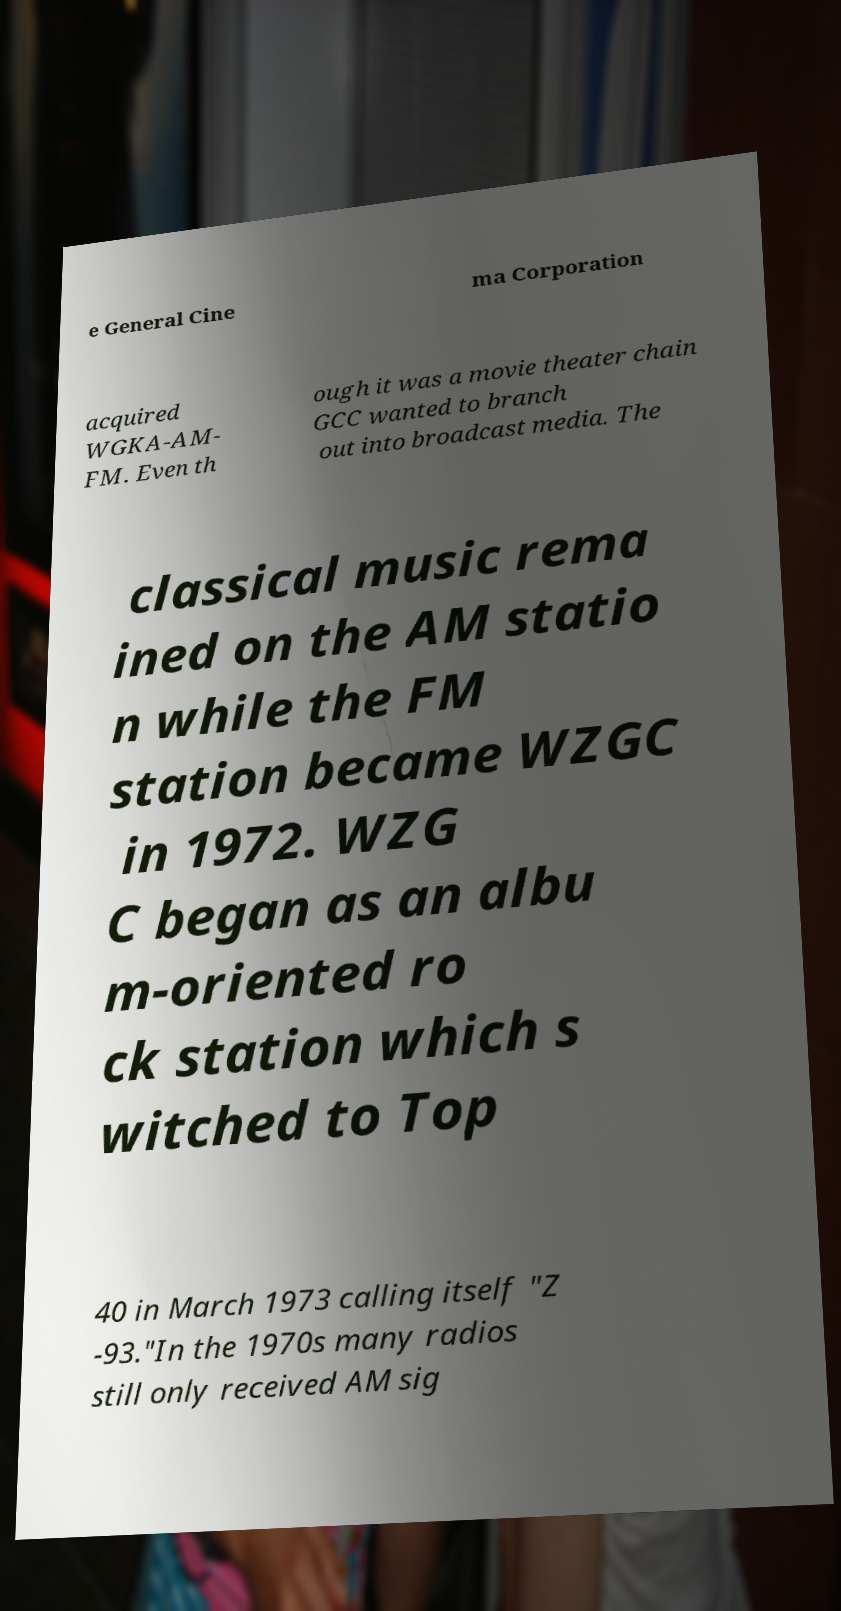Can you read and provide the text displayed in the image?This photo seems to have some interesting text. Can you extract and type it out for me? e General Cine ma Corporation acquired WGKA-AM- FM. Even th ough it was a movie theater chain GCC wanted to branch out into broadcast media. The classical music rema ined on the AM statio n while the FM station became WZGC in 1972. WZG C began as an albu m-oriented ro ck station which s witched to Top 40 in March 1973 calling itself "Z -93."In the 1970s many radios still only received AM sig 